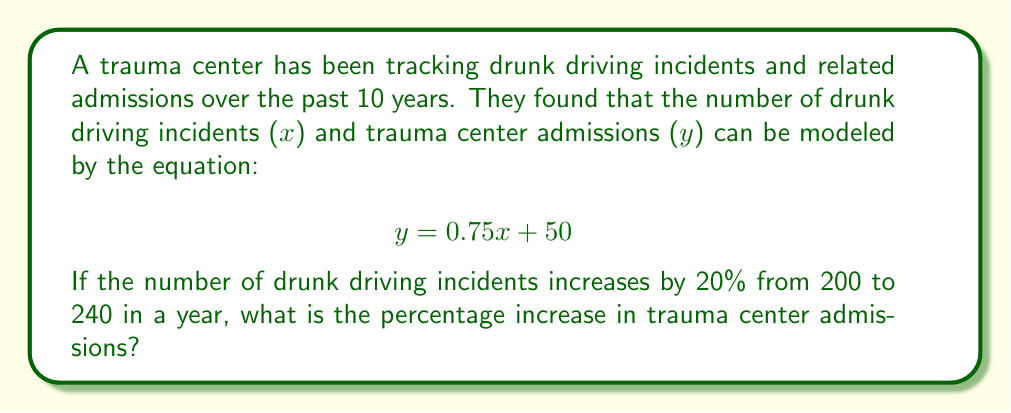Could you help me with this problem? 1) First, let's calculate the initial number of trauma center admissions when x = 200:
   $$ y_1 = 0.75(200) + 50 = 150 + 50 = 200 $$

2) Now, let's calculate the number of trauma center admissions when x = 240:
   $$ y_2 = 0.75(240) + 50 = 180 + 50 = 230 $$

3) To find the percentage increase, we use the formula:
   $$ \text{Percentage Increase} = \frac{\text{Increase}}{\text{Original Value}} \times 100\% $$

4) The increase in admissions is:
   $$ 230 - 200 = 30 $$

5) Applying the percentage increase formula:
   $$ \text{Percentage Increase} = \frac{30}{200} \times 100\% = 0.15 \times 100\% = 15\% $$

Therefore, the trauma center admissions increased by 15%.
Answer: 15% 